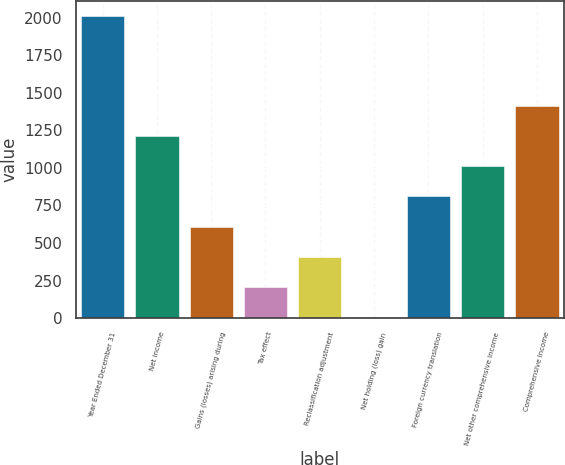Convert chart. <chart><loc_0><loc_0><loc_500><loc_500><bar_chart><fcel>Year Ended December 31<fcel>Net income<fcel>Gains (losses) arising during<fcel>Tax effect<fcel>Reclassification adjustment<fcel>Net holding (loss) gain<fcel>Foreign currency translation<fcel>Net other comprehensive income<fcel>Comprehensive Income<nl><fcel>2013<fcel>1211.12<fcel>609.71<fcel>208.77<fcel>409.24<fcel>8.3<fcel>810.18<fcel>1010.65<fcel>1411.59<nl></chart> 